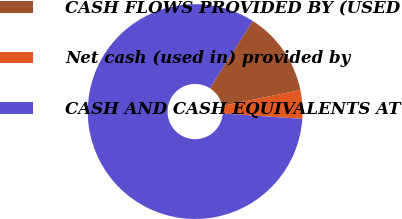Convert chart. <chart><loc_0><loc_0><loc_500><loc_500><pie_chart><fcel>CASH FLOWS PROVIDED BY (USED<fcel>Net cash (used in) provided by<fcel>CASH AND CASH EQUIVALENTS AT<nl><fcel>12.78%<fcel>4.31%<fcel>82.92%<nl></chart> 